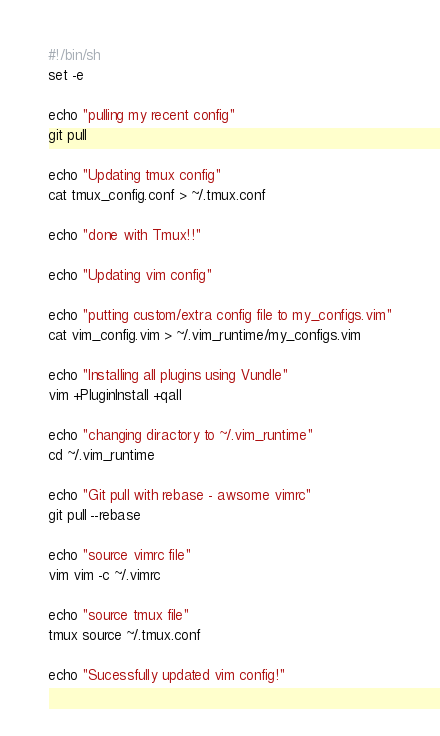Convert code to text. <code><loc_0><loc_0><loc_500><loc_500><_Bash_>#!/bin/sh
set -e

echo "pulling my recent config"
git pull

echo "Updating tmux config"
cat tmux_config.conf > ~/.tmux.conf

echo "done with Tmux!!"

echo "Updating vim config"

echo "putting custom/extra config file to my_configs.vim"
cat vim_config.vim > ~/.vim_runtime/my_configs.vim

echo "Installing all plugins using Vundle"
vim +PluginInstall +qall

echo "changing diractory to ~/.vim_runtime"
cd ~/.vim_runtime

echo "Git pull with rebase - awsome vimrc"
git pull --rebase

echo "source vimrc file"
vim vim -c ~/.vimrc

echo "source tmux file"
tmux source ~/.tmux.conf

echo "Sucessfully updated vim config!"
</code> 